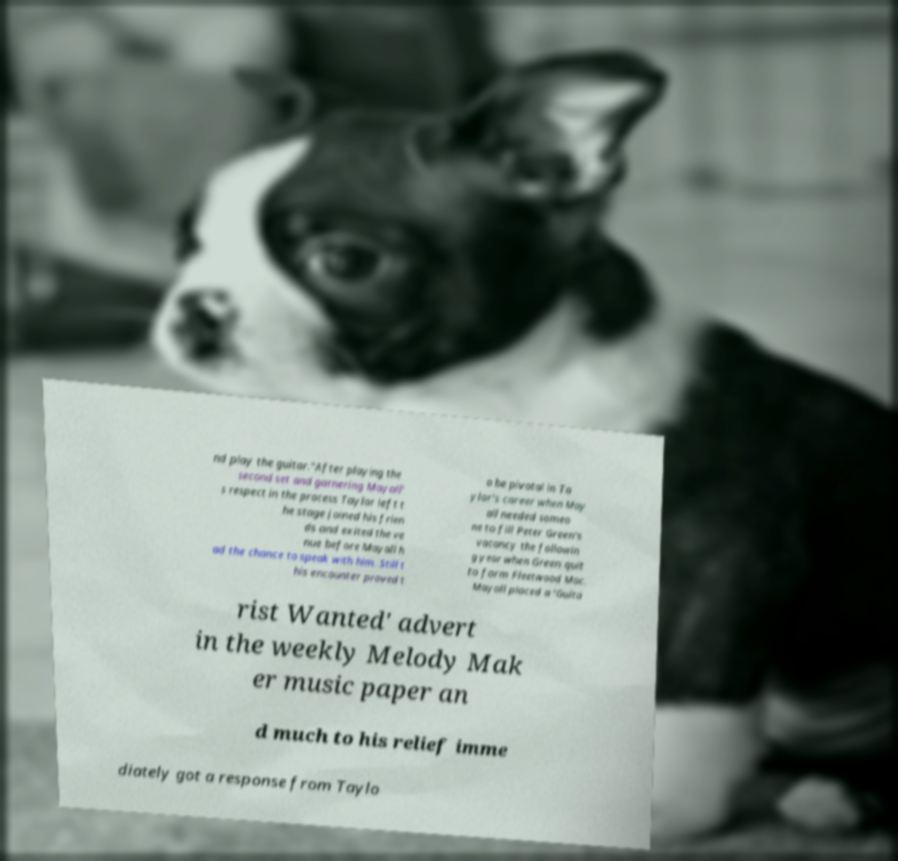I need the written content from this picture converted into text. Can you do that? nd play the guitar."After playing the second set and garnering Mayall' s respect in the process Taylor left t he stage joined his frien ds and exited the ve nue before Mayall h ad the chance to speak with him. Still t his encounter proved t o be pivotal in Ta ylor's career when May all needed someo ne to fill Peter Green's vacancy the followin g year when Green quit to form Fleetwood Mac. Mayall placed a 'Guita rist Wanted' advert in the weekly Melody Mak er music paper an d much to his relief imme diately got a response from Taylo 